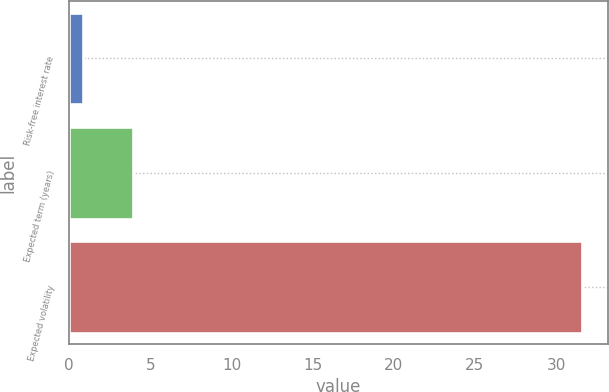Convert chart to OTSL. <chart><loc_0><loc_0><loc_500><loc_500><bar_chart><fcel>Risk-free interest rate<fcel>Expected term (years)<fcel>Expected volatility<nl><fcel>0.83<fcel>3.91<fcel>31.59<nl></chart> 